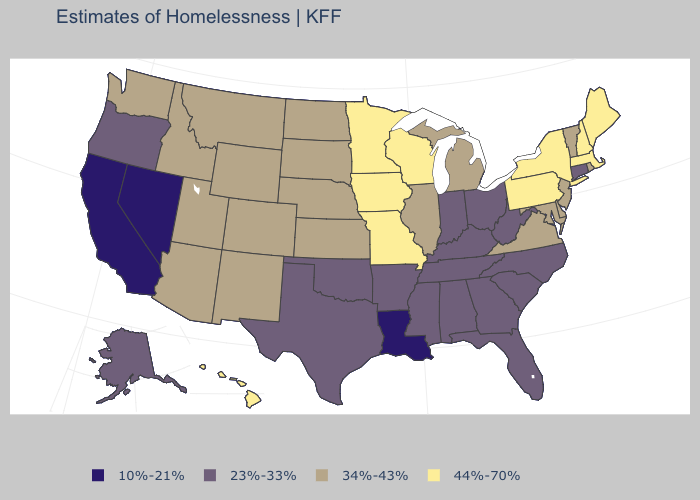What is the highest value in the MidWest ?
Quick response, please. 44%-70%. Among the states that border Missouri , which have the highest value?
Short answer required. Iowa. Does the first symbol in the legend represent the smallest category?
Be succinct. Yes. What is the value of Washington?
Short answer required. 34%-43%. What is the lowest value in states that border North Carolina?
Give a very brief answer. 23%-33%. What is the value of Maine?
Keep it brief. 44%-70%. What is the lowest value in the USA?
Short answer required. 10%-21%. Among the states that border Indiana , does Ohio have the highest value?
Keep it brief. No. Does New Hampshire have the highest value in the USA?
Quick response, please. Yes. What is the highest value in states that border Minnesota?
Short answer required. 44%-70%. What is the highest value in the USA?
Short answer required. 44%-70%. Name the states that have a value in the range 44%-70%?
Be succinct. Hawaii, Iowa, Maine, Massachusetts, Minnesota, Missouri, New Hampshire, New York, Pennsylvania, Wisconsin. What is the highest value in the USA?
Be succinct. 44%-70%. Name the states that have a value in the range 23%-33%?
Give a very brief answer. Alabama, Alaska, Arkansas, Connecticut, Florida, Georgia, Indiana, Kentucky, Mississippi, North Carolina, Ohio, Oklahoma, Oregon, South Carolina, Tennessee, Texas, West Virginia. What is the highest value in the MidWest ?
Keep it brief. 44%-70%. 